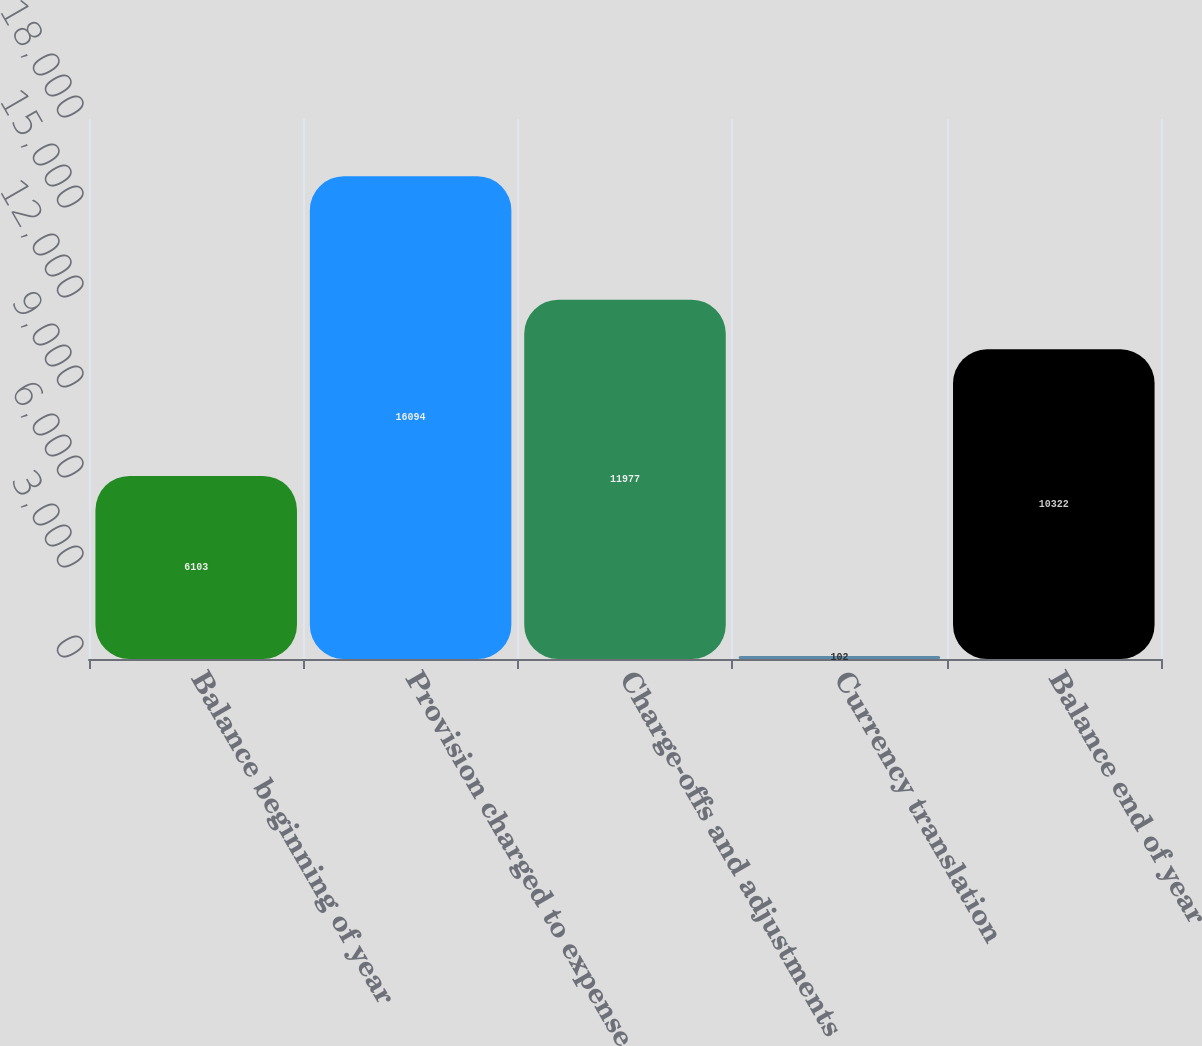<chart> <loc_0><loc_0><loc_500><loc_500><bar_chart><fcel>Balance beginning of year<fcel>Provision charged to expense<fcel>Charge-offs and adjustments<fcel>Currency translation<fcel>Balance end of year<nl><fcel>6103<fcel>16094<fcel>11977<fcel>102<fcel>10322<nl></chart> 